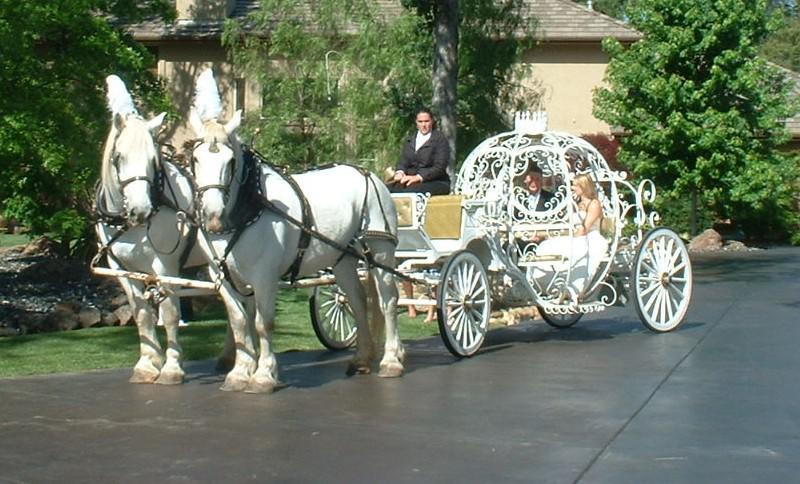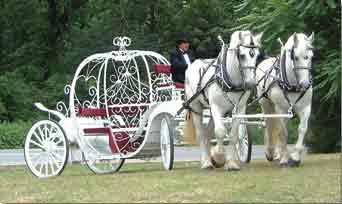The first image is the image on the left, the second image is the image on the right. Evaluate the accuracy of this statement regarding the images: "The left image shows a carriage pulled by a brown horse.". Is it true? Answer yes or no. No. 